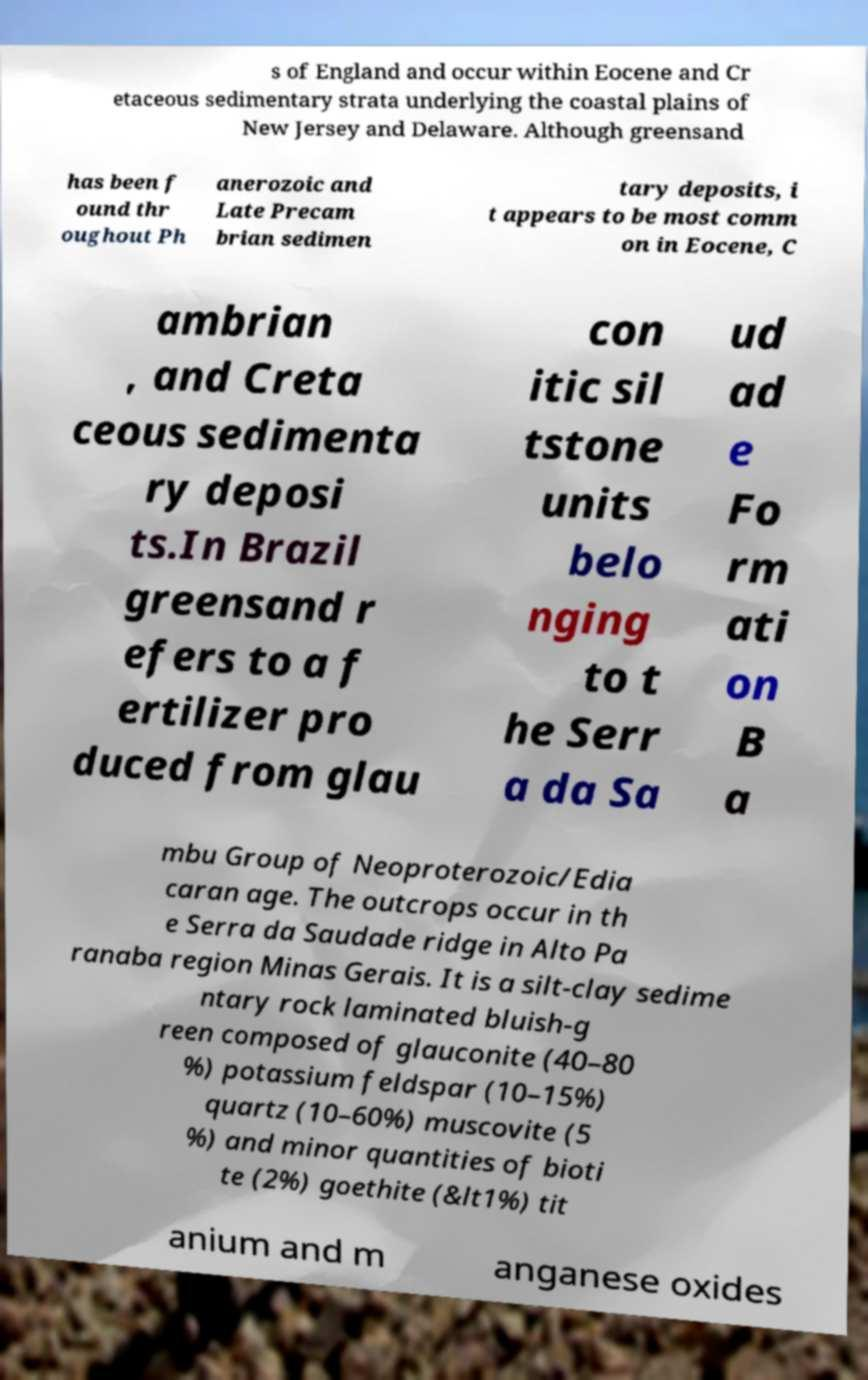Can you read and provide the text displayed in the image?This photo seems to have some interesting text. Can you extract and type it out for me? s of England and occur within Eocene and Cr etaceous sedimentary strata underlying the coastal plains of New Jersey and Delaware. Although greensand has been f ound thr oughout Ph anerozoic and Late Precam brian sedimen tary deposits, i t appears to be most comm on in Eocene, C ambrian , and Creta ceous sedimenta ry deposi ts.In Brazil greensand r efers to a f ertilizer pro duced from glau con itic sil tstone units belo nging to t he Serr a da Sa ud ad e Fo rm ati on B a mbu Group of Neoproterozoic/Edia caran age. The outcrops occur in th e Serra da Saudade ridge in Alto Pa ranaba region Minas Gerais. It is a silt-clay sedime ntary rock laminated bluish-g reen composed of glauconite (40–80 %) potassium feldspar (10–15%) quartz (10–60%) muscovite (5 %) and minor quantities of bioti te (2%) goethite (&lt1%) tit anium and m anganese oxides 